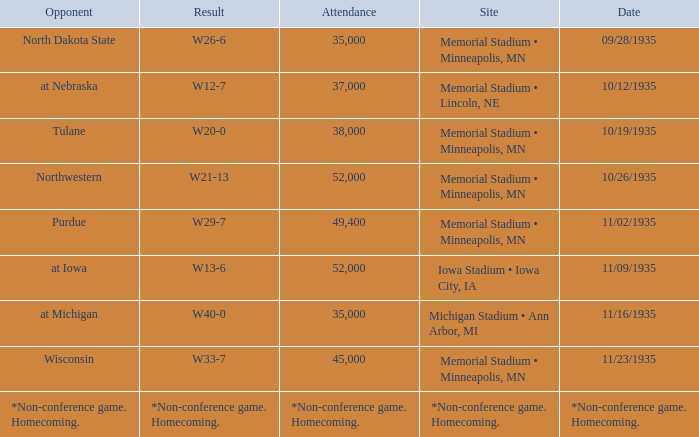Can you give me this table as a dict? {'header': ['Opponent', 'Result', 'Attendance', 'Site', 'Date'], 'rows': [['North Dakota State', 'W26-6', '35,000', 'Memorial Stadium • Minneapolis, MN', '09/28/1935'], ['at Nebraska', 'W12-7', '37,000', 'Memorial Stadium • Lincoln, NE', '10/12/1935'], ['Tulane', 'W20-0', '38,000', 'Memorial Stadium • Minneapolis, MN', '10/19/1935'], ['Northwestern', 'W21-13', '52,000', 'Memorial Stadium • Minneapolis, MN', '10/26/1935'], ['Purdue', 'W29-7', '49,400', 'Memorial Stadium • Minneapolis, MN', '11/02/1935'], ['at Iowa', 'W13-6', '52,000', 'Iowa Stadium • Iowa City, IA', '11/09/1935'], ['at Michigan', 'W40-0', '35,000', 'Michigan Stadium • Ann Arbor, MI', '11/16/1935'], ['Wisconsin', 'W33-7', '45,000', 'Memorial Stadium • Minneapolis, MN', '11/23/1935'], ['*Non-conference game. Homecoming.', '*Non-conference game. Homecoming.', '*Non-conference game. Homecoming.', '*Non-conference game. Homecoming.', '*Non-conference game. Homecoming.']]} How many spectators attended the game on 11/09/1935? 52000.0. 